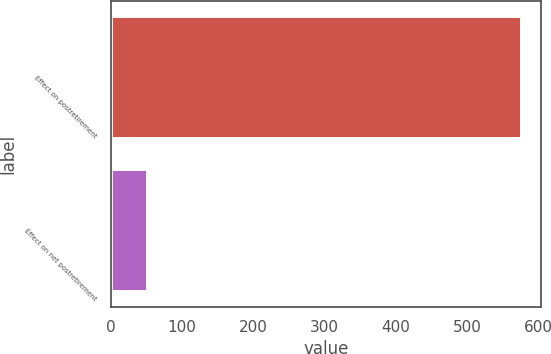Convert chart to OTSL. <chart><loc_0><loc_0><loc_500><loc_500><bar_chart><fcel>Effect on postretirement<fcel>Effect on net postretirement<nl><fcel>575<fcel>51<nl></chart> 